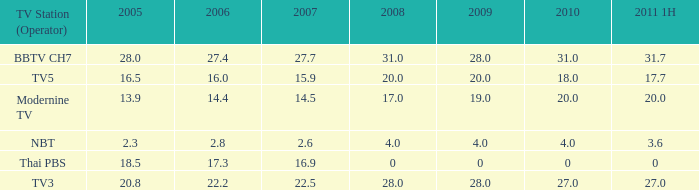How many 2011 1H values have a 2006 of 27.4 and 2007 over 27.7? 0.0. 